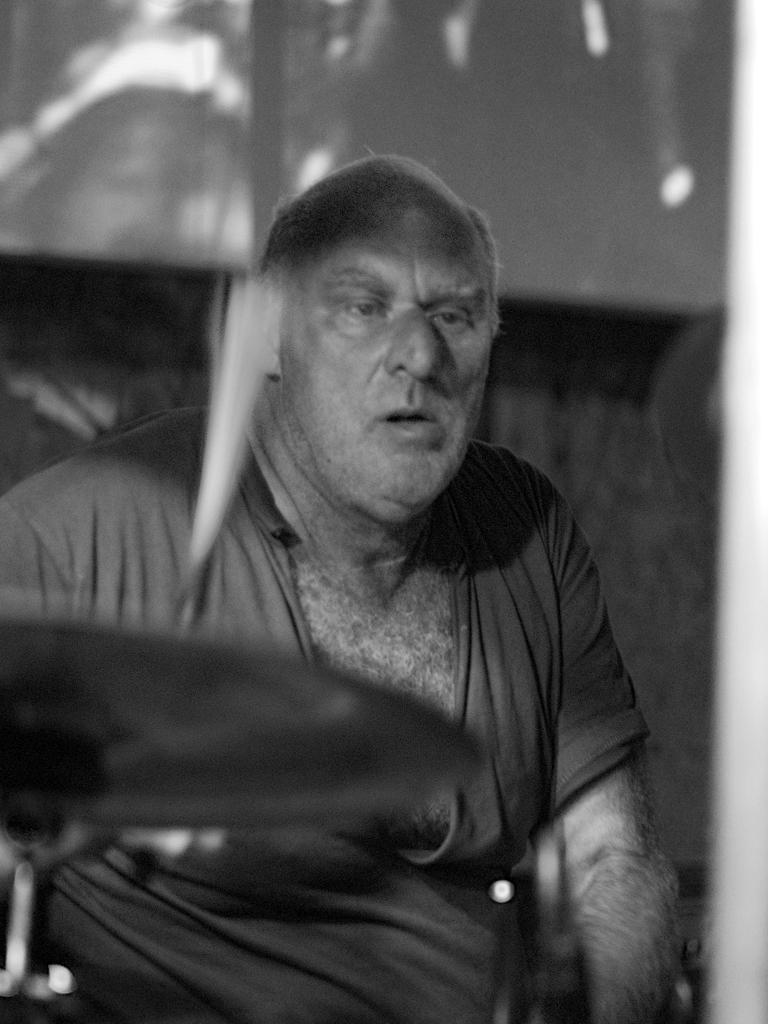In one or two sentences, can you explain what this image depicts? This is a black and white image which is slightly blurred, where I can see a person wearing T-shirt is holding sticks in his hands and here we can see electronic drums. In the background, I can see the wall. 